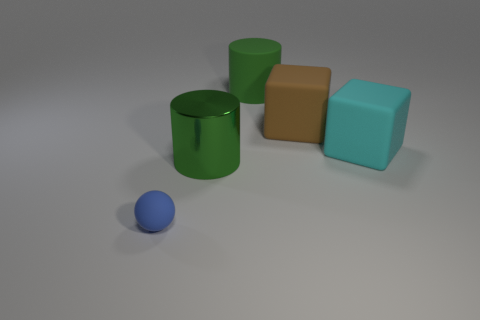Add 4 small blue matte things. How many objects exist? 9 Subtract all balls. How many objects are left? 4 Subtract all small rubber cubes. Subtract all green matte things. How many objects are left? 4 Add 1 shiny things. How many shiny things are left? 2 Add 4 matte blocks. How many matte blocks exist? 6 Subtract 0 cyan balls. How many objects are left? 5 